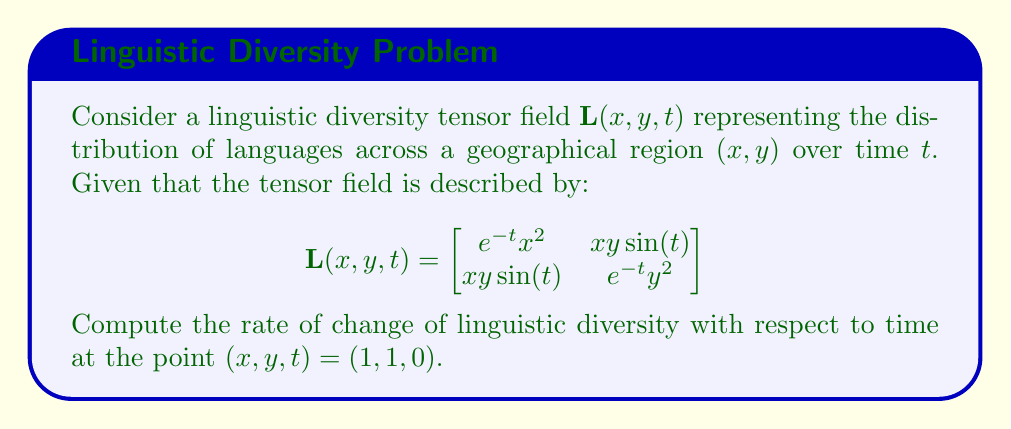Show me your answer to this math problem. To solve this problem, we need to follow these steps:

1) The rate of change of linguistic diversity with respect to time is given by the partial derivative of $\mathbf{L}$ with respect to $t$:

   $$\frac{\partial \mathbf{L}}{\partial t} = \begin{bmatrix}
   \frac{\partial L_{11}}{\partial t} & \frac{\partial L_{12}}{\partial t} \\
   \frac{\partial L_{21}}{\partial t} & \frac{\partial L_{22}}{\partial t}
   \end{bmatrix}$$

2) Let's compute each element:

   $$\frac{\partial L_{11}}{\partial t} = \frac{\partial}{\partial t}(e^{-t}x^2) = -e^{-t}x^2$$
   
   $$\frac{\partial L_{12}}{\partial t} = \frac{\partial L_{21}}{\partial t} = \frac{\partial}{\partial t}(xy\sin(t)) = xy\cos(t)$$
   
   $$\frac{\partial L_{22}}{\partial t} = \frac{\partial}{\partial t}(e^{-t}y^2) = -e^{-t}y^2$$

3) Therefore, the rate of change tensor is:

   $$\frac{\partial \mathbf{L}}{\partial t} = \begin{bmatrix}
   -e^{-t}x^2 & xy\cos(t) \\
   xy\cos(t) & -e^{-t}y^2
   \end{bmatrix}$$

4) Now, we need to evaluate this at the point $(x, y, t) = (1, 1, 0)$:

   $$\frac{\partial \mathbf{L}}{\partial t}\bigg|_{(1,1,0)} = \begin{bmatrix}
   -e^{0}(1)^2 & (1)(1)\cos(0) \\
   (1)(1)\cos(0) & -e^{0}(1)^2
   \end{bmatrix} = \begin{bmatrix}
   -1 & 1 \\
   1 & -1
   \end{bmatrix}$$

This tensor represents the instantaneous rate of change of linguistic diversity at the given point.
Answer: $$\begin{bmatrix}
-1 & 1 \\
1 & -1
\end{bmatrix}$$ 